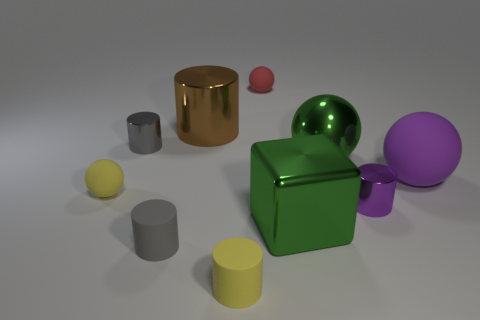Subtract all yellow spheres. Subtract all green cubes. How many spheres are left? 3 Subtract all spheres. How many objects are left? 6 Add 5 tiny purple metal cylinders. How many tiny purple metal cylinders exist? 6 Subtract 0 green cylinders. How many objects are left? 10 Subtract all green shiny spheres. Subtract all big metallic blocks. How many objects are left? 8 Add 4 cubes. How many cubes are left? 5 